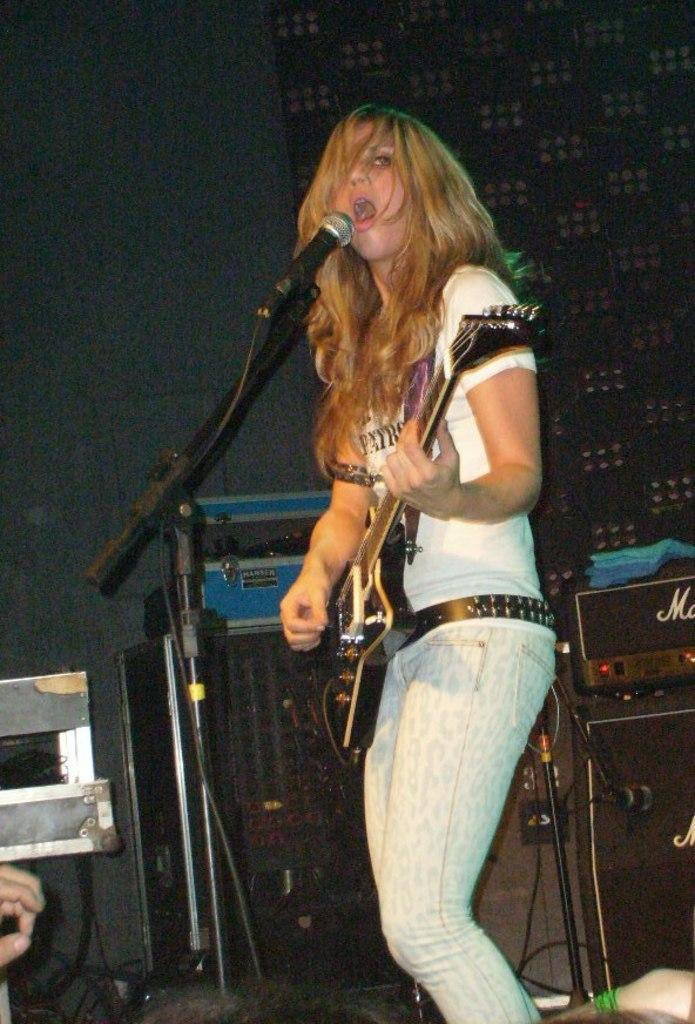Who is the main subject in the image? There is a woman in the image. What is the woman doing in the image? The woman is playing a guitar and singing a song. Where is the woman positioned in the image? The woman is in front of a microphone. What else can be seen in the image related to music? There is a music system visible in the image. What type of plot is the rabbit running through in the image? There is no rabbit or plot present in the image; it features a woman playing a guitar and singing. 